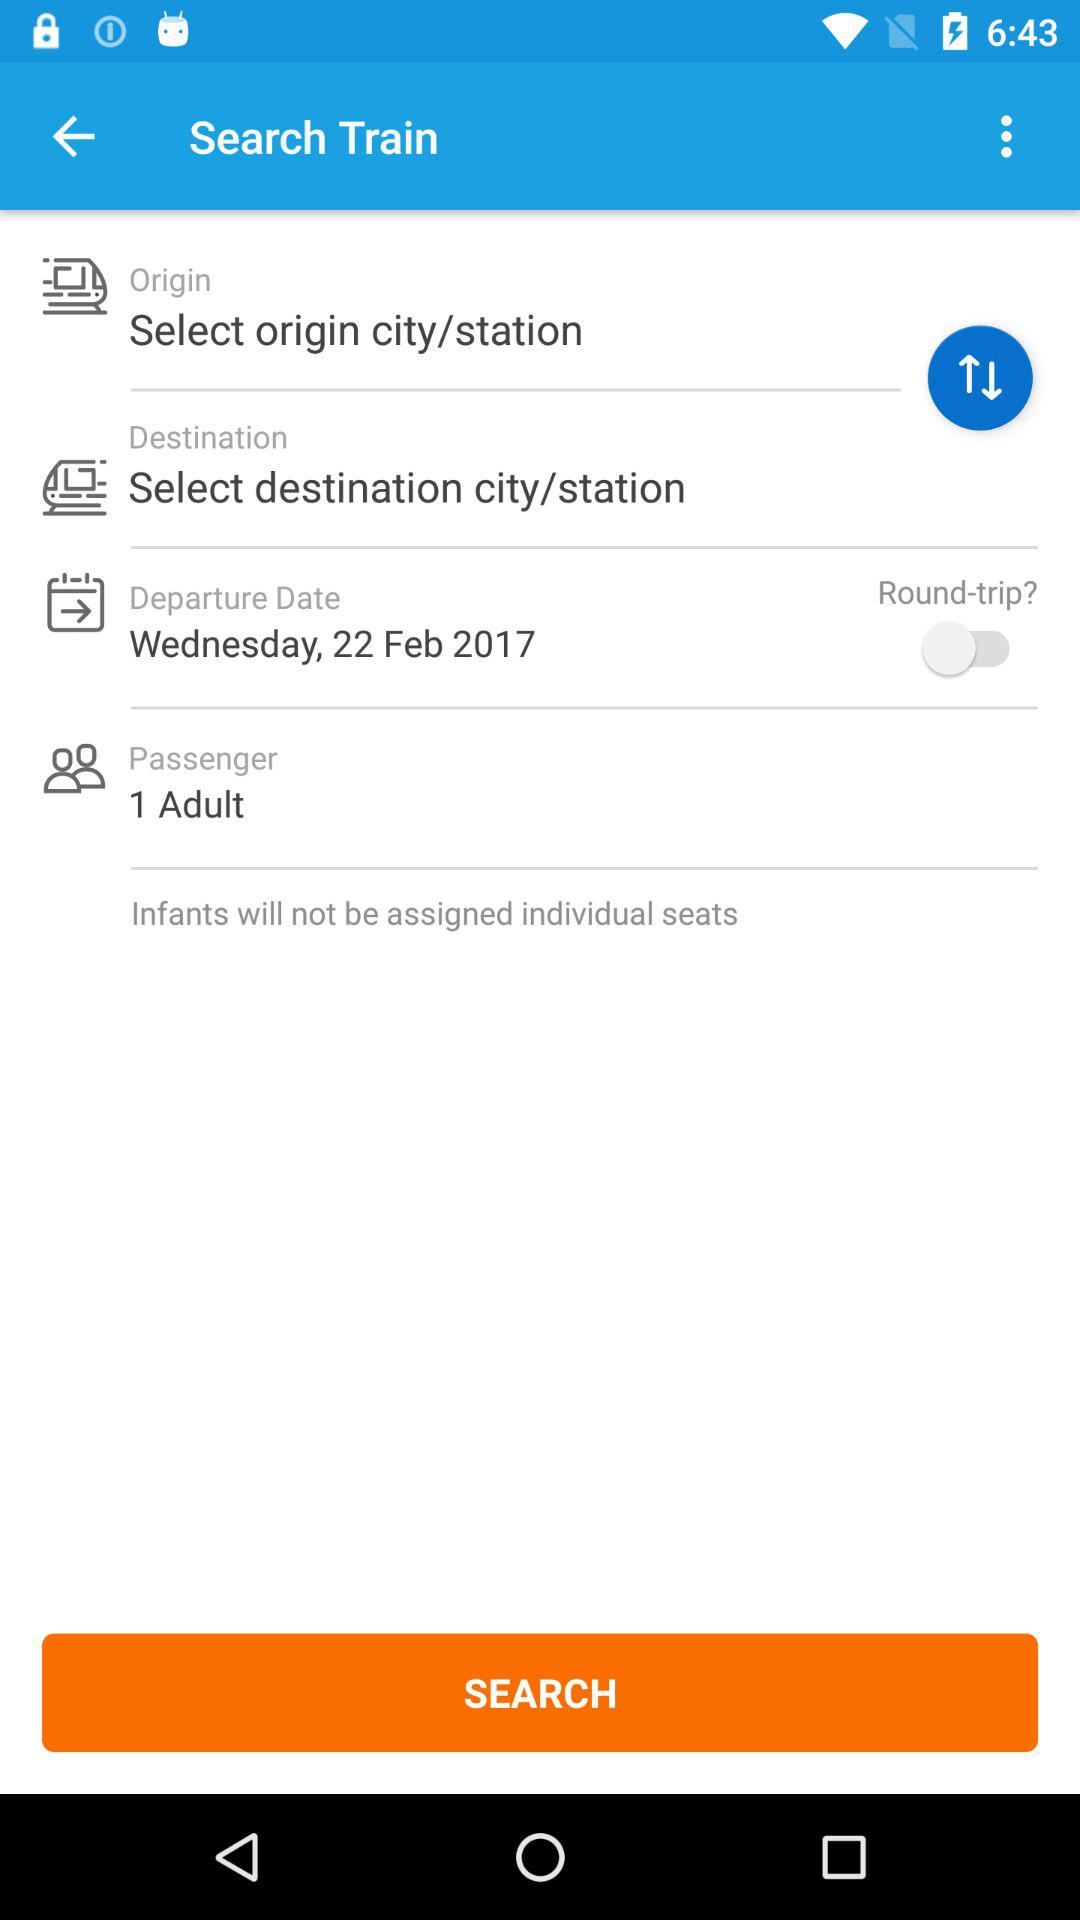What is the status of "Round-trip"? The status is "off". 